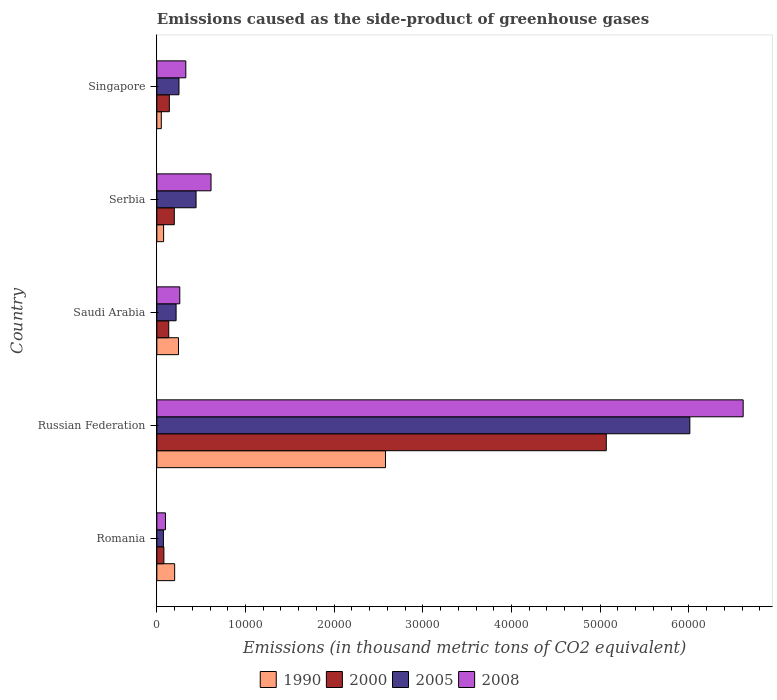How many different coloured bars are there?
Provide a short and direct response. 4. Are the number of bars per tick equal to the number of legend labels?
Your answer should be very brief. Yes. How many bars are there on the 2nd tick from the bottom?
Your answer should be very brief. 4. What is the label of the 2nd group of bars from the top?
Your response must be concise. Serbia. In how many cases, is the number of bars for a given country not equal to the number of legend labels?
Make the answer very short. 0. What is the emissions caused as the side-product of greenhouse gases in 2005 in Saudi Arabia?
Ensure brevity in your answer.  2170.7. Across all countries, what is the maximum emissions caused as the side-product of greenhouse gases in 2008?
Offer a very short reply. 6.61e+04. Across all countries, what is the minimum emissions caused as the side-product of greenhouse gases in 2000?
Make the answer very short. 795.1. In which country was the emissions caused as the side-product of greenhouse gases in 2000 maximum?
Offer a very short reply. Russian Federation. In which country was the emissions caused as the side-product of greenhouse gases in 2005 minimum?
Provide a short and direct response. Romania. What is the total emissions caused as the side-product of greenhouse gases in 1990 in the graph?
Your response must be concise. 3.15e+04. What is the difference between the emissions caused as the side-product of greenhouse gases in 2000 in Romania and that in Saudi Arabia?
Give a very brief answer. -545. What is the difference between the emissions caused as the side-product of greenhouse gases in 2008 in Romania and the emissions caused as the side-product of greenhouse gases in 2000 in Singapore?
Your response must be concise. -439.3. What is the average emissions caused as the side-product of greenhouse gases in 2008 per country?
Give a very brief answer. 1.58e+04. What is the difference between the emissions caused as the side-product of greenhouse gases in 1990 and emissions caused as the side-product of greenhouse gases in 2005 in Saudi Arabia?
Provide a succinct answer. 270.7. In how many countries, is the emissions caused as the side-product of greenhouse gases in 2005 greater than 56000 thousand metric tons?
Ensure brevity in your answer.  1. What is the ratio of the emissions caused as the side-product of greenhouse gases in 2000 in Russian Federation to that in Saudi Arabia?
Provide a succinct answer. 37.82. What is the difference between the highest and the second highest emissions caused as the side-product of greenhouse gases in 2005?
Offer a terse response. 5.57e+04. What is the difference between the highest and the lowest emissions caused as the side-product of greenhouse gases in 2008?
Make the answer very short. 6.52e+04. Is the sum of the emissions caused as the side-product of greenhouse gases in 2000 in Romania and Singapore greater than the maximum emissions caused as the side-product of greenhouse gases in 2005 across all countries?
Provide a short and direct response. No. Is it the case that in every country, the sum of the emissions caused as the side-product of greenhouse gases in 2000 and emissions caused as the side-product of greenhouse gases in 2005 is greater than the sum of emissions caused as the side-product of greenhouse gases in 1990 and emissions caused as the side-product of greenhouse gases in 2008?
Keep it short and to the point. No. What does the 2nd bar from the top in Russian Federation represents?
Keep it short and to the point. 2005. Is it the case that in every country, the sum of the emissions caused as the side-product of greenhouse gases in 2005 and emissions caused as the side-product of greenhouse gases in 2008 is greater than the emissions caused as the side-product of greenhouse gases in 2000?
Ensure brevity in your answer.  Yes. How many countries are there in the graph?
Offer a terse response. 5. Are the values on the major ticks of X-axis written in scientific E-notation?
Provide a succinct answer. No. Where does the legend appear in the graph?
Ensure brevity in your answer.  Bottom center. How many legend labels are there?
Give a very brief answer. 4. How are the legend labels stacked?
Provide a short and direct response. Horizontal. What is the title of the graph?
Provide a succinct answer. Emissions caused as the side-product of greenhouse gases. What is the label or title of the X-axis?
Provide a short and direct response. Emissions (in thousand metric tons of CO2 equivalent). What is the label or title of the Y-axis?
Your answer should be very brief. Country. What is the Emissions (in thousand metric tons of CO2 equivalent) of 1990 in Romania?
Your answer should be compact. 2007.7. What is the Emissions (in thousand metric tons of CO2 equivalent) of 2000 in Romania?
Offer a terse response. 795.1. What is the Emissions (in thousand metric tons of CO2 equivalent) of 2005 in Romania?
Offer a very short reply. 742.3. What is the Emissions (in thousand metric tons of CO2 equivalent) in 2008 in Romania?
Keep it short and to the point. 970.3. What is the Emissions (in thousand metric tons of CO2 equivalent) in 1990 in Russian Federation?
Provide a succinct answer. 2.58e+04. What is the Emissions (in thousand metric tons of CO2 equivalent) in 2000 in Russian Federation?
Provide a succinct answer. 5.07e+04. What is the Emissions (in thousand metric tons of CO2 equivalent) of 2005 in Russian Federation?
Your response must be concise. 6.01e+04. What is the Emissions (in thousand metric tons of CO2 equivalent) of 2008 in Russian Federation?
Your answer should be very brief. 6.61e+04. What is the Emissions (in thousand metric tons of CO2 equivalent) in 1990 in Saudi Arabia?
Provide a succinct answer. 2441.4. What is the Emissions (in thousand metric tons of CO2 equivalent) in 2000 in Saudi Arabia?
Ensure brevity in your answer.  1340.1. What is the Emissions (in thousand metric tons of CO2 equivalent) of 2005 in Saudi Arabia?
Provide a succinct answer. 2170.7. What is the Emissions (in thousand metric tons of CO2 equivalent) of 2008 in Saudi Arabia?
Your answer should be very brief. 2588.3. What is the Emissions (in thousand metric tons of CO2 equivalent) in 1990 in Serbia?
Give a very brief answer. 762.4. What is the Emissions (in thousand metric tons of CO2 equivalent) in 2000 in Serbia?
Give a very brief answer. 1968.1. What is the Emissions (in thousand metric tons of CO2 equivalent) in 2005 in Serbia?
Offer a terse response. 4422.8. What is the Emissions (in thousand metric tons of CO2 equivalent) in 2008 in Serbia?
Offer a very short reply. 6111.3. What is the Emissions (in thousand metric tons of CO2 equivalent) of 1990 in Singapore?
Make the answer very short. 501.5. What is the Emissions (in thousand metric tons of CO2 equivalent) of 2000 in Singapore?
Provide a succinct answer. 1409.6. What is the Emissions (in thousand metric tons of CO2 equivalent) of 2005 in Singapore?
Your answer should be very brief. 2496.4. What is the Emissions (in thousand metric tons of CO2 equivalent) in 2008 in Singapore?
Your answer should be very brief. 3266.4. Across all countries, what is the maximum Emissions (in thousand metric tons of CO2 equivalent) of 1990?
Make the answer very short. 2.58e+04. Across all countries, what is the maximum Emissions (in thousand metric tons of CO2 equivalent) of 2000?
Ensure brevity in your answer.  5.07e+04. Across all countries, what is the maximum Emissions (in thousand metric tons of CO2 equivalent) of 2005?
Your response must be concise. 6.01e+04. Across all countries, what is the maximum Emissions (in thousand metric tons of CO2 equivalent) in 2008?
Your answer should be very brief. 6.61e+04. Across all countries, what is the minimum Emissions (in thousand metric tons of CO2 equivalent) in 1990?
Your answer should be very brief. 501.5. Across all countries, what is the minimum Emissions (in thousand metric tons of CO2 equivalent) in 2000?
Make the answer very short. 795.1. Across all countries, what is the minimum Emissions (in thousand metric tons of CO2 equivalent) of 2005?
Provide a succinct answer. 742.3. Across all countries, what is the minimum Emissions (in thousand metric tons of CO2 equivalent) of 2008?
Provide a short and direct response. 970.3. What is the total Emissions (in thousand metric tons of CO2 equivalent) of 1990 in the graph?
Your response must be concise. 3.15e+04. What is the total Emissions (in thousand metric tons of CO2 equivalent) in 2000 in the graph?
Provide a short and direct response. 5.62e+04. What is the total Emissions (in thousand metric tons of CO2 equivalent) in 2005 in the graph?
Provide a succinct answer. 6.99e+04. What is the total Emissions (in thousand metric tons of CO2 equivalent) of 2008 in the graph?
Provide a succinct answer. 7.91e+04. What is the difference between the Emissions (in thousand metric tons of CO2 equivalent) of 1990 in Romania and that in Russian Federation?
Your answer should be very brief. -2.38e+04. What is the difference between the Emissions (in thousand metric tons of CO2 equivalent) of 2000 in Romania and that in Russian Federation?
Give a very brief answer. -4.99e+04. What is the difference between the Emissions (in thousand metric tons of CO2 equivalent) of 2005 in Romania and that in Russian Federation?
Provide a succinct answer. -5.94e+04. What is the difference between the Emissions (in thousand metric tons of CO2 equivalent) of 2008 in Romania and that in Russian Federation?
Provide a succinct answer. -6.52e+04. What is the difference between the Emissions (in thousand metric tons of CO2 equivalent) in 1990 in Romania and that in Saudi Arabia?
Your response must be concise. -433.7. What is the difference between the Emissions (in thousand metric tons of CO2 equivalent) in 2000 in Romania and that in Saudi Arabia?
Provide a short and direct response. -545. What is the difference between the Emissions (in thousand metric tons of CO2 equivalent) in 2005 in Romania and that in Saudi Arabia?
Ensure brevity in your answer.  -1428.4. What is the difference between the Emissions (in thousand metric tons of CO2 equivalent) in 2008 in Romania and that in Saudi Arabia?
Provide a short and direct response. -1618. What is the difference between the Emissions (in thousand metric tons of CO2 equivalent) of 1990 in Romania and that in Serbia?
Your answer should be very brief. 1245.3. What is the difference between the Emissions (in thousand metric tons of CO2 equivalent) in 2000 in Romania and that in Serbia?
Ensure brevity in your answer.  -1173. What is the difference between the Emissions (in thousand metric tons of CO2 equivalent) in 2005 in Romania and that in Serbia?
Make the answer very short. -3680.5. What is the difference between the Emissions (in thousand metric tons of CO2 equivalent) in 2008 in Romania and that in Serbia?
Provide a short and direct response. -5141. What is the difference between the Emissions (in thousand metric tons of CO2 equivalent) of 1990 in Romania and that in Singapore?
Your answer should be compact. 1506.2. What is the difference between the Emissions (in thousand metric tons of CO2 equivalent) in 2000 in Romania and that in Singapore?
Provide a succinct answer. -614.5. What is the difference between the Emissions (in thousand metric tons of CO2 equivalent) of 2005 in Romania and that in Singapore?
Give a very brief answer. -1754.1. What is the difference between the Emissions (in thousand metric tons of CO2 equivalent) in 2008 in Romania and that in Singapore?
Provide a short and direct response. -2296.1. What is the difference between the Emissions (in thousand metric tons of CO2 equivalent) of 1990 in Russian Federation and that in Saudi Arabia?
Give a very brief answer. 2.33e+04. What is the difference between the Emissions (in thousand metric tons of CO2 equivalent) of 2000 in Russian Federation and that in Saudi Arabia?
Offer a very short reply. 4.93e+04. What is the difference between the Emissions (in thousand metric tons of CO2 equivalent) of 2005 in Russian Federation and that in Saudi Arabia?
Keep it short and to the point. 5.79e+04. What is the difference between the Emissions (in thousand metric tons of CO2 equivalent) of 2008 in Russian Federation and that in Saudi Arabia?
Your answer should be very brief. 6.35e+04. What is the difference between the Emissions (in thousand metric tons of CO2 equivalent) of 1990 in Russian Federation and that in Serbia?
Provide a succinct answer. 2.50e+04. What is the difference between the Emissions (in thousand metric tons of CO2 equivalent) of 2000 in Russian Federation and that in Serbia?
Offer a terse response. 4.87e+04. What is the difference between the Emissions (in thousand metric tons of CO2 equivalent) of 2005 in Russian Federation and that in Serbia?
Your response must be concise. 5.57e+04. What is the difference between the Emissions (in thousand metric tons of CO2 equivalent) of 2008 in Russian Federation and that in Serbia?
Offer a terse response. 6.00e+04. What is the difference between the Emissions (in thousand metric tons of CO2 equivalent) of 1990 in Russian Federation and that in Singapore?
Your answer should be very brief. 2.53e+04. What is the difference between the Emissions (in thousand metric tons of CO2 equivalent) in 2000 in Russian Federation and that in Singapore?
Ensure brevity in your answer.  4.93e+04. What is the difference between the Emissions (in thousand metric tons of CO2 equivalent) of 2005 in Russian Federation and that in Singapore?
Give a very brief answer. 5.76e+04. What is the difference between the Emissions (in thousand metric tons of CO2 equivalent) of 2008 in Russian Federation and that in Singapore?
Ensure brevity in your answer.  6.29e+04. What is the difference between the Emissions (in thousand metric tons of CO2 equivalent) of 1990 in Saudi Arabia and that in Serbia?
Provide a short and direct response. 1679. What is the difference between the Emissions (in thousand metric tons of CO2 equivalent) of 2000 in Saudi Arabia and that in Serbia?
Your answer should be compact. -628. What is the difference between the Emissions (in thousand metric tons of CO2 equivalent) of 2005 in Saudi Arabia and that in Serbia?
Offer a terse response. -2252.1. What is the difference between the Emissions (in thousand metric tons of CO2 equivalent) in 2008 in Saudi Arabia and that in Serbia?
Offer a terse response. -3523. What is the difference between the Emissions (in thousand metric tons of CO2 equivalent) in 1990 in Saudi Arabia and that in Singapore?
Your answer should be very brief. 1939.9. What is the difference between the Emissions (in thousand metric tons of CO2 equivalent) of 2000 in Saudi Arabia and that in Singapore?
Your response must be concise. -69.5. What is the difference between the Emissions (in thousand metric tons of CO2 equivalent) in 2005 in Saudi Arabia and that in Singapore?
Keep it short and to the point. -325.7. What is the difference between the Emissions (in thousand metric tons of CO2 equivalent) of 2008 in Saudi Arabia and that in Singapore?
Give a very brief answer. -678.1. What is the difference between the Emissions (in thousand metric tons of CO2 equivalent) in 1990 in Serbia and that in Singapore?
Your answer should be very brief. 260.9. What is the difference between the Emissions (in thousand metric tons of CO2 equivalent) of 2000 in Serbia and that in Singapore?
Your answer should be very brief. 558.5. What is the difference between the Emissions (in thousand metric tons of CO2 equivalent) in 2005 in Serbia and that in Singapore?
Offer a very short reply. 1926.4. What is the difference between the Emissions (in thousand metric tons of CO2 equivalent) in 2008 in Serbia and that in Singapore?
Keep it short and to the point. 2844.9. What is the difference between the Emissions (in thousand metric tons of CO2 equivalent) in 1990 in Romania and the Emissions (in thousand metric tons of CO2 equivalent) in 2000 in Russian Federation?
Keep it short and to the point. -4.87e+04. What is the difference between the Emissions (in thousand metric tons of CO2 equivalent) in 1990 in Romania and the Emissions (in thousand metric tons of CO2 equivalent) in 2005 in Russian Federation?
Your response must be concise. -5.81e+04. What is the difference between the Emissions (in thousand metric tons of CO2 equivalent) in 1990 in Romania and the Emissions (in thousand metric tons of CO2 equivalent) in 2008 in Russian Federation?
Your response must be concise. -6.41e+04. What is the difference between the Emissions (in thousand metric tons of CO2 equivalent) in 2000 in Romania and the Emissions (in thousand metric tons of CO2 equivalent) in 2005 in Russian Federation?
Provide a short and direct response. -5.93e+04. What is the difference between the Emissions (in thousand metric tons of CO2 equivalent) of 2000 in Romania and the Emissions (in thousand metric tons of CO2 equivalent) of 2008 in Russian Federation?
Make the answer very short. -6.53e+04. What is the difference between the Emissions (in thousand metric tons of CO2 equivalent) of 2005 in Romania and the Emissions (in thousand metric tons of CO2 equivalent) of 2008 in Russian Federation?
Give a very brief answer. -6.54e+04. What is the difference between the Emissions (in thousand metric tons of CO2 equivalent) of 1990 in Romania and the Emissions (in thousand metric tons of CO2 equivalent) of 2000 in Saudi Arabia?
Give a very brief answer. 667.6. What is the difference between the Emissions (in thousand metric tons of CO2 equivalent) in 1990 in Romania and the Emissions (in thousand metric tons of CO2 equivalent) in 2005 in Saudi Arabia?
Offer a very short reply. -163. What is the difference between the Emissions (in thousand metric tons of CO2 equivalent) in 1990 in Romania and the Emissions (in thousand metric tons of CO2 equivalent) in 2008 in Saudi Arabia?
Your response must be concise. -580.6. What is the difference between the Emissions (in thousand metric tons of CO2 equivalent) in 2000 in Romania and the Emissions (in thousand metric tons of CO2 equivalent) in 2005 in Saudi Arabia?
Your answer should be very brief. -1375.6. What is the difference between the Emissions (in thousand metric tons of CO2 equivalent) in 2000 in Romania and the Emissions (in thousand metric tons of CO2 equivalent) in 2008 in Saudi Arabia?
Offer a terse response. -1793.2. What is the difference between the Emissions (in thousand metric tons of CO2 equivalent) of 2005 in Romania and the Emissions (in thousand metric tons of CO2 equivalent) of 2008 in Saudi Arabia?
Keep it short and to the point. -1846. What is the difference between the Emissions (in thousand metric tons of CO2 equivalent) of 1990 in Romania and the Emissions (in thousand metric tons of CO2 equivalent) of 2000 in Serbia?
Keep it short and to the point. 39.6. What is the difference between the Emissions (in thousand metric tons of CO2 equivalent) in 1990 in Romania and the Emissions (in thousand metric tons of CO2 equivalent) in 2005 in Serbia?
Offer a very short reply. -2415.1. What is the difference between the Emissions (in thousand metric tons of CO2 equivalent) in 1990 in Romania and the Emissions (in thousand metric tons of CO2 equivalent) in 2008 in Serbia?
Your answer should be compact. -4103.6. What is the difference between the Emissions (in thousand metric tons of CO2 equivalent) in 2000 in Romania and the Emissions (in thousand metric tons of CO2 equivalent) in 2005 in Serbia?
Provide a short and direct response. -3627.7. What is the difference between the Emissions (in thousand metric tons of CO2 equivalent) of 2000 in Romania and the Emissions (in thousand metric tons of CO2 equivalent) of 2008 in Serbia?
Provide a succinct answer. -5316.2. What is the difference between the Emissions (in thousand metric tons of CO2 equivalent) in 2005 in Romania and the Emissions (in thousand metric tons of CO2 equivalent) in 2008 in Serbia?
Provide a short and direct response. -5369. What is the difference between the Emissions (in thousand metric tons of CO2 equivalent) of 1990 in Romania and the Emissions (in thousand metric tons of CO2 equivalent) of 2000 in Singapore?
Offer a terse response. 598.1. What is the difference between the Emissions (in thousand metric tons of CO2 equivalent) in 1990 in Romania and the Emissions (in thousand metric tons of CO2 equivalent) in 2005 in Singapore?
Your answer should be very brief. -488.7. What is the difference between the Emissions (in thousand metric tons of CO2 equivalent) of 1990 in Romania and the Emissions (in thousand metric tons of CO2 equivalent) of 2008 in Singapore?
Provide a short and direct response. -1258.7. What is the difference between the Emissions (in thousand metric tons of CO2 equivalent) of 2000 in Romania and the Emissions (in thousand metric tons of CO2 equivalent) of 2005 in Singapore?
Offer a terse response. -1701.3. What is the difference between the Emissions (in thousand metric tons of CO2 equivalent) in 2000 in Romania and the Emissions (in thousand metric tons of CO2 equivalent) in 2008 in Singapore?
Ensure brevity in your answer.  -2471.3. What is the difference between the Emissions (in thousand metric tons of CO2 equivalent) of 2005 in Romania and the Emissions (in thousand metric tons of CO2 equivalent) of 2008 in Singapore?
Your response must be concise. -2524.1. What is the difference between the Emissions (in thousand metric tons of CO2 equivalent) in 1990 in Russian Federation and the Emissions (in thousand metric tons of CO2 equivalent) in 2000 in Saudi Arabia?
Ensure brevity in your answer.  2.44e+04. What is the difference between the Emissions (in thousand metric tons of CO2 equivalent) of 1990 in Russian Federation and the Emissions (in thousand metric tons of CO2 equivalent) of 2005 in Saudi Arabia?
Your response must be concise. 2.36e+04. What is the difference between the Emissions (in thousand metric tons of CO2 equivalent) of 1990 in Russian Federation and the Emissions (in thousand metric tons of CO2 equivalent) of 2008 in Saudi Arabia?
Provide a succinct answer. 2.32e+04. What is the difference between the Emissions (in thousand metric tons of CO2 equivalent) of 2000 in Russian Federation and the Emissions (in thousand metric tons of CO2 equivalent) of 2005 in Saudi Arabia?
Provide a short and direct response. 4.85e+04. What is the difference between the Emissions (in thousand metric tons of CO2 equivalent) of 2000 in Russian Federation and the Emissions (in thousand metric tons of CO2 equivalent) of 2008 in Saudi Arabia?
Provide a short and direct response. 4.81e+04. What is the difference between the Emissions (in thousand metric tons of CO2 equivalent) in 2005 in Russian Federation and the Emissions (in thousand metric tons of CO2 equivalent) in 2008 in Saudi Arabia?
Keep it short and to the point. 5.75e+04. What is the difference between the Emissions (in thousand metric tons of CO2 equivalent) of 1990 in Russian Federation and the Emissions (in thousand metric tons of CO2 equivalent) of 2000 in Serbia?
Offer a terse response. 2.38e+04. What is the difference between the Emissions (in thousand metric tons of CO2 equivalent) in 1990 in Russian Federation and the Emissions (in thousand metric tons of CO2 equivalent) in 2005 in Serbia?
Your response must be concise. 2.14e+04. What is the difference between the Emissions (in thousand metric tons of CO2 equivalent) in 1990 in Russian Federation and the Emissions (in thousand metric tons of CO2 equivalent) in 2008 in Serbia?
Ensure brevity in your answer.  1.97e+04. What is the difference between the Emissions (in thousand metric tons of CO2 equivalent) of 2000 in Russian Federation and the Emissions (in thousand metric tons of CO2 equivalent) of 2005 in Serbia?
Your response must be concise. 4.63e+04. What is the difference between the Emissions (in thousand metric tons of CO2 equivalent) of 2000 in Russian Federation and the Emissions (in thousand metric tons of CO2 equivalent) of 2008 in Serbia?
Offer a very short reply. 4.46e+04. What is the difference between the Emissions (in thousand metric tons of CO2 equivalent) in 2005 in Russian Federation and the Emissions (in thousand metric tons of CO2 equivalent) in 2008 in Serbia?
Give a very brief answer. 5.40e+04. What is the difference between the Emissions (in thousand metric tons of CO2 equivalent) of 1990 in Russian Federation and the Emissions (in thousand metric tons of CO2 equivalent) of 2000 in Singapore?
Keep it short and to the point. 2.44e+04. What is the difference between the Emissions (in thousand metric tons of CO2 equivalent) of 1990 in Russian Federation and the Emissions (in thousand metric tons of CO2 equivalent) of 2005 in Singapore?
Make the answer very short. 2.33e+04. What is the difference between the Emissions (in thousand metric tons of CO2 equivalent) in 1990 in Russian Federation and the Emissions (in thousand metric tons of CO2 equivalent) in 2008 in Singapore?
Your answer should be compact. 2.25e+04. What is the difference between the Emissions (in thousand metric tons of CO2 equivalent) of 2000 in Russian Federation and the Emissions (in thousand metric tons of CO2 equivalent) of 2005 in Singapore?
Your response must be concise. 4.82e+04. What is the difference between the Emissions (in thousand metric tons of CO2 equivalent) of 2000 in Russian Federation and the Emissions (in thousand metric tons of CO2 equivalent) of 2008 in Singapore?
Your answer should be very brief. 4.74e+04. What is the difference between the Emissions (in thousand metric tons of CO2 equivalent) of 2005 in Russian Federation and the Emissions (in thousand metric tons of CO2 equivalent) of 2008 in Singapore?
Make the answer very short. 5.68e+04. What is the difference between the Emissions (in thousand metric tons of CO2 equivalent) in 1990 in Saudi Arabia and the Emissions (in thousand metric tons of CO2 equivalent) in 2000 in Serbia?
Ensure brevity in your answer.  473.3. What is the difference between the Emissions (in thousand metric tons of CO2 equivalent) of 1990 in Saudi Arabia and the Emissions (in thousand metric tons of CO2 equivalent) of 2005 in Serbia?
Provide a short and direct response. -1981.4. What is the difference between the Emissions (in thousand metric tons of CO2 equivalent) in 1990 in Saudi Arabia and the Emissions (in thousand metric tons of CO2 equivalent) in 2008 in Serbia?
Provide a succinct answer. -3669.9. What is the difference between the Emissions (in thousand metric tons of CO2 equivalent) of 2000 in Saudi Arabia and the Emissions (in thousand metric tons of CO2 equivalent) of 2005 in Serbia?
Make the answer very short. -3082.7. What is the difference between the Emissions (in thousand metric tons of CO2 equivalent) of 2000 in Saudi Arabia and the Emissions (in thousand metric tons of CO2 equivalent) of 2008 in Serbia?
Make the answer very short. -4771.2. What is the difference between the Emissions (in thousand metric tons of CO2 equivalent) in 2005 in Saudi Arabia and the Emissions (in thousand metric tons of CO2 equivalent) in 2008 in Serbia?
Offer a very short reply. -3940.6. What is the difference between the Emissions (in thousand metric tons of CO2 equivalent) in 1990 in Saudi Arabia and the Emissions (in thousand metric tons of CO2 equivalent) in 2000 in Singapore?
Your answer should be compact. 1031.8. What is the difference between the Emissions (in thousand metric tons of CO2 equivalent) in 1990 in Saudi Arabia and the Emissions (in thousand metric tons of CO2 equivalent) in 2005 in Singapore?
Provide a short and direct response. -55. What is the difference between the Emissions (in thousand metric tons of CO2 equivalent) of 1990 in Saudi Arabia and the Emissions (in thousand metric tons of CO2 equivalent) of 2008 in Singapore?
Ensure brevity in your answer.  -825. What is the difference between the Emissions (in thousand metric tons of CO2 equivalent) in 2000 in Saudi Arabia and the Emissions (in thousand metric tons of CO2 equivalent) in 2005 in Singapore?
Offer a terse response. -1156.3. What is the difference between the Emissions (in thousand metric tons of CO2 equivalent) of 2000 in Saudi Arabia and the Emissions (in thousand metric tons of CO2 equivalent) of 2008 in Singapore?
Offer a very short reply. -1926.3. What is the difference between the Emissions (in thousand metric tons of CO2 equivalent) in 2005 in Saudi Arabia and the Emissions (in thousand metric tons of CO2 equivalent) in 2008 in Singapore?
Give a very brief answer. -1095.7. What is the difference between the Emissions (in thousand metric tons of CO2 equivalent) in 1990 in Serbia and the Emissions (in thousand metric tons of CO2 equivalent) in 2000 in Singapore?
Your answer should be compact. -647.2. What is the difference between the Emissions (in thousand metric tons of CO2 equivalent) of 1990 in Serbia and the Emissions (in thousand metric tons of CO2 equivalent) of 2005 in Singapore?
Give a very brief answer. -1734. What is the difference between the Emissions (in thousand metric tons of CO2 equivalent) of 1990 in Serbia and the Emissions (in thousand metric tons of CO2 equivalent) of 2008 in Singapore?
Give a very brief answer. -2504. What is the difference between the Emissions (in thousand metric tons of CO2 equivalent) in 2000 in Serbia and the Emissions (in thousand metric tons of CO2 equivalent) in 2005 in Singapore?
Give a very brief answer. -528.3. What is the difference between the Emissions (in thousand metric tons of CO2 equivalent) of 2000 in Serbia and the Emissions (in thousand metric tons of CO2 equivalent) of 2008 in Singapore?
Give a very brief answer. -1298.3. What is the difference between the Emissions (in thousand metric tons of CO2 equivalent) in 2005 in Serbia and the Emissions (in thousand metric tons of CO2 equivalent) in 2008 in Singapore?
Offer a very short reply. 1156.4. What is the average Emissions (in thousand metric tons of CO2 equivalent) of 1990 per country?
Provide a short and direct response. 6300.32. What is the average Emissions (in thousand metric tons of CO2 equivalent) in 2000 per country?
Your answer should be very brief. 1.12e+04. What is the average Emissions (in thousand metric tons of CO2 equivalent) of 2005 per country?
Provide a succinct answer. 1.40e+04. What is the average Emissions (in thousand metric tons of CO2 equivalent) in 2008 per country?
Ensure brevity in your answer.  1.58e+04. What is the difference between the Emissions (in thousand metric tons of CO2 equivalent) in 1990 and Emissions (in thousand metric tons of CO2 equivalent) in 2000 in Romania?
Your answer should be very brief. 1212.6. What is the difference between the Emissions (in thousand metric tons of CO2 equivalent) of 1990 and Emissions (in thousand metric tons of CO2 equivalent) of 2005 in Romania?
Keep it short and to the point. 1265.4. What is the difference between the Emissions (in thousand metric tons of CO2 equivalent) in 1990 and Emissions (in thousand metric tons of CO2 equivalent) in 2008 in Romania?
Provide a short and direct response. 1037.4. What is the difference between the Emissions (in thousand metric tons of CO2 equivalent) of 2000 and Emissions (in thousand metric tons of CO2 equivalent) of 2005 in Romania?
Provide a succinct answer. 52.8. What is the difference between the Emissions (in thousand metric tons of CO2 equivalent) of 2000 and Emissions (in thousand metric tons of CO2 equivalent) of 2008 in Romania?
Give a very brief answer. -175.2. What is the difference between the Emissions (in thousand metric tons of CO2 equivalent) in 2005 and Emissions (in thousand metric tons of CO2 equivalent) in 2008 in Romania?
Your answer should be very brief. -228. What is the difference between the Emissions (in thousand metric tons of CO2 equivalent) in 1990 and Emissions (in thousand metric tons of CO2 equivalent) in 2000 in Russian Federation?
Ensure brevity in your answer.  -2.49e+04. What is the difference between the Emissions (in thousand metric tons of CO2 equivalent) of 1990 and Emissions (in thousand metric tons of CO2 equivalent) of 2005 in Russian Federation?
Provide a short and direct response. -3.43e+04. What is the difference between the Emissions (in thousand metric tons of CO2 equivalent) in 1990 and Emissions (in thousand metric tons of CO2 equivalent) in 2008 in Russian Federation?
Give a very brief answer. -4.03e+04. What is the difference between the Emissions (in thousand metric tons of CO2 equivalent) in 2000 and Emissions (in thousand metric tons of CO2 equivalent) in 2005 in Russian Federation?
Offer a terse response. -9424.5. What is the difference between the Emissions (in thousand metric tons of CO2 equivalent) in 2000 and Emissions (in thousand metric tons of CO2 equivalent) in 2008 in Russian Federation?
Your answer should be very brief. -1.54e+04. What is the difference between the Emissions (in thousand metric tons of CO2 equivalent) in 2005 and Emissions (in thousand metric tons of CO2 equivalent) in 2008 in Russian Federation?
Give a very brief answer. -6015. What is the difference between the Emissions (in thousand metric tons of CO2 equivalent) of 1990 and Emissions (in thousand metric tons of CO2 equivalent) of 2000 in Saudi Arabia?
Your answer should be compact. 1101.3. What is the difference between the Emissions (in thousand metric tons of CO2 equivalent) in 1990 and Emissions (in thousand metric tons of CO2 equivalent) in 2005 in Saudi Arabia?
Your answer should be compact. 270.7. What is the difference between the Emissions (in thousand metric tons of CO2 equivalent) of 1990 and Emissions (in thousand metric tons of CO2 equivalent) of 2008 in Saudi Arabia?
Keep it short and to the point. -146.9. What is the difference between the Emissions (in thousand metric tons of CO2 equivalent) in 2000 and Emissions (in thousand metric tons of CO2 equivalent) in 2005 in Saudi Arabia?
Give a very brief answer. -830.6. What is the difference between the Emissions (in thousand metric tons of CO2 equivalent) in 2000 and Emissions (in thousand metric tons of CO2 equivalent) in 2008 in Saudi Arabia?
Your answer should be very brief. -1248.2. What is the difference between the Emissions (in thousand metric tons of CO2 equivalent) in 2005 and Emissions (in thousand metric tons of CO2 equivalent) in 2008 in Saudi Arabia?
Ensure brevity in your answer.  -417.6. What is the difference between the Emissions (in thousand metric tons of CO2 equivalent) in 1990 and Emissions (in thousand metric tons of CO2 equivalent) in 2000 in Serbia?
Offer a terse response. -1205.7. What is the difference between the Emissions (in thousand metric tons of CO2 equivalent) of 1990 and Emissions (in thousand metric tons of CO2 equivalent) of 2005 in Serbia?
Give a very brief answer. -3660.4. What is the difference between the Emissions (in thousand metric tons of CO2 equivalent) of 1990 and Emissions (in thousand metric tons of CO2 equivalent) of 2008 in Serbia?
Give a very brief answer. -5348.9. What is the difference between the Emissions (in thousand metric tons of CO2 equivalent) of 2000 and Emissions (in thousand metric tons of CO2 equivalent) of 2005 in Serbia?
Provide a short and direct response. -2454.7. What is the difference between the Emissions (in thousand metric tons of CO2 equivalent) in 2000 and Emissions (in thousand metric tons of CO2 equivalent) in 2008 in Serbia?
Give a very brief answer. -4143.2. What is the difference between the Emissions (in thousand metric tons of CO2 equivalent) in 2005 and Emissions (in thousand metric tons of CO2 equivalent) in 2008 in Serbia?
Provide a succinct answer. -1688.5. What is the difference between the Emissions (in thousand metric tons of CO2 equivalent) of 1990 and Emissions (in thousand metric tons of CO2 equivalent) of 2000 in Singapore?
Your response must be concise. -908.1. What is the difference between the Emissions (in thousand metric tons of CO2 equivalent) in 1990 and Emissions (in thousand metric tons of CO2 equivalent) in 2005 in Singapore?
Provide a succinct answer. -1994.9. What is the difference between the Emissions (in thousand metric tons of CO2 equivalent) in 1990 and Emissions (in thousand metric tons of CO2 equivalent) in 2008 in Singapore?
Make the answer very short. -2764.9. What is the difference between the Emissions (in thousand metric tons of CO2 equivalent) of 2000 and Emissions (in thousand metric tons of CO2 equivalent) of 2005 in Singapore?
Your response must be concise. -1086.8. What is the difference between the Emissions (in thousand metric tons of CO2 equivalent) of 2000 and Emissions (in thousand metric tons of CO2 equivalent) of 2008 in Singapore?
Keep it short and to the point. -1856.8. What is the difference between the Emissions (in thousand metric tons of CO2 equivalent) of 2005 and Emissions (in thousand metric tons of CO2 equivalent) of 2008 in Singapore?
Offer a terse response. -770. What is the ratio of the Emissions (in thousand metric tons of CO2 equivalent) of 1990 in Romania to that in Russian Federation?
Keep it short and to the point. 0.08. What is the ratio of the Emissions (in thousand metric tons of CO2 equivalent) of 2000 in Romania to that in Russian Federation?
Keep it short and to the point. 0.02. What is the ratio of the Emissions (in thousand metric tons of CO2 equivalent) of 2005 in Romania to that in Russian Federation?
Keep it short and to the point. 0.01. What is the ratio of the Emissions (in thousand metric tons of CO2 equivalent) in 2008 in Romania to that in Russian Federation?
Offer a very short reply. 0.01. What is the ratio of the Emissions (in thousand metric tons of CO2 equivalent) in 1990 in Romania to that in Saudi Arabia?
Keep it short and to the point. 0.82. What is the ratio of the Emissions (in thousand metric tons of CO2 equivalent) in 2000 in Romania to that in Saudi Arabia?
Offer a terse response. 0.59. What is the ratio of the Emissions (in thousand metric tons of CO2 equivalent) of 2005 in Romania to that in Saudi Arabia?
Offer a terse response. 0.34. What is the ratio of the Emissions (in thousand metric tons of CO2 equivalent) of 2008 in Romania to that in Saudi Arabia?
Your response must be concise. 0.37. What is the ratio of the Emissions (in thousand metric tons of CO2 equivalent) in 1990 in Romania to that in Serbia?
Provide a short and direct response. 2.63. What is the ratio of the Emissions (in thousand metric tons of CO2 equivalent) in 2000 in Romania to that in Serbia?
Make the answer very short. 0.4. What is the ratio of the Emissions (in thousand metric tons of CO2 equivalent) of 2005 in Romania to that in Serbia?
Ensure brevity in your answer.  0.17. What is the ratio of the Emissions (in thousand metric tons of CO2 equivalent) of 2008 in Romania to that in Serbia?
Offer a terse response. 0.16. What is the ratio of the Emissions (in thousand metric tons of CO2 equivalent) in 1990 in Romania to that in Singapore?
Your answer should be very brief. 4. What is the ratio of the Emissions (in thousand metric tons of CO2 equivalent) of 2000 in Romania to that in Singapore?
Your answer should be compact. 0.56. What is the ratio of the Emissions (in thousand metric tons of CO2 equivalent) in 2005 in Romania to that in Singapore?
Make the answer very short. 0.3. What is the ratio of the Emissions (in thousand metric tons of CO2 equivalent) of 2008 in Romania to that in Singapore?
Offer a very short reply. 0.3. What is the ratio of the Emissions (in thousand metric tons of CO2 equivalent) in 1990 in Russian Federation to that in Saudi Arabia?
Your answer should be very brief. 10.56. What is the ratio of the Emissions (in thousand metric tons of CO2 equivalent) in 2000 in Russian Federation to that in Saudi Arabia?
Your answer should be very brief. 37.82. What is the ratio of the Emissions (in thousand metric tons of CO2 equivalent) of 2005 in Russian Federation to that in Saudi Arabia?
Give a very brief answer. 27.69. What is the ratio of the Emissions (in thousand metric tons of CO2 equivalent) in 2008 in Russian Federation to that in Saudi Arabia?
Provide a succinct answer. 25.55. What is the ratio of the Emissions (in thousand metric tons of CO2 equivalent) in 1990 in Russian Federation to that in Serbia?
Offer a very short reply. 33.83. What is the ratio of the Emissions (in thousand metric tons of CO2 equivalent) of 2000 in Russian Federation to that in Serbia?
Provide a succinct answer. 25.75. What is the ratio of the Emissions (in thousand metric tons of CO2 equivalent) of 2005 in Russian Federation to that in Serbia?
Give a very brief answer. 13.59. What is the ratio of the Emissions (in thousand metric tons of CO2 equivalent) of 2008 in Russian Federation to that in Serbia?
Provide a succinct answer. 10.82. What is the ratio of the Emissions (in thousand metric tons of CO2 equivalent) in 1990 in Russian Federation to that in Singapore?
Make the answer very short. 51.42. What is the ratio of the Emissions (in thousand metric tons of CO2 equivalent) of 2000 in Russian Federation to that in Singapore?
Offer a terse response. 35.96. What is the ratio of the Emissions (in thousand metric tons of CO2 equivalent) of 2005 in Russian Federation to that in Singapore?
Offer a terse response. 24.08. What is the ratio of the Emissions (in thousand metric tons of CO2 equivalent) in 2008 in Russian Federation to that in Singapore?
Ensure brevity in your answer.  20.24. What is the ratio of the Emissions (in thousand metric tons of CO2 equivalent) of 1990 in Saudi Arabia to that in Serbia?
Offer a terse response. 3.2. What is the ratio of the Emissions (in thousand metric tons of CO2 equivalent) of 2000 in Saudi Arabia to that in Serbia?
Offer a very short reply. 0.68. What is the ratio of the Emissions (in thousand metric tons of CO2 equivalent) in 2005 in Saudi Arabia to that in Serbia?
Provide a short and direct response. 0.49. What is the ratio of the Emissions (in thousand metric tons of CO2 equivalent) in 2008 in Saudi Arabia to that in Serbia?
Make the answer very short. 0.42. What is the ratio of the Emissions (in thousand metric tons of CO2 equivalent) in 1990 in Saudi Arabia to that in Singapore?
Give a very brief answer. 4.87. What is the ratio of the Emissions (in thousand metric tons of CO2 equivalent) of 2000 in Saudi Arabia to that in Singapore?
Make the answer very short. 0.95. What is the ratio of the Emissions (in thousand metric tons of CO2 equivalent) in 2005 in Saudi Arabia to that in Singapore?
Keep it short and to the point. 0.87. What is the ratio of the Emissions (in thousand metric tons of CO2 equivalent) in 2008 in Saudi Arabia to that in Singapore?
Your answer should be compact. 0.79. What is the ratio of the Emissions (in thousand metric tons of CO2 equivalent) of 1990 in Serbia to that in Singapore?
Provide a short and direct response. 1.52. What is the ratio of the Emissions (in thousand metric tons of CO2 equivalent) in 2000 in Serbia to that in Singapore?
Give a very brief answer. 1.4. What is the ratio of the Emissions (in thousand metric tons of CO2 equivalent) in 2005 in Serbia to that in Singapore?
Make the answer very short. 1.77. What is the ratio of the Emissions (in thousand metric tons of CO2 equivalent) of 2008 in Serbia to that in Singapore?
Provide a succinct answer. 1.87. What is the difference between the highest and the second highest Emissions (in thousand metric tons of CO2 equivalent) in 1990?
Keep it short and to the point. 2.33e+04. What is the difference between the highest and the second highest Emissions (in thousand metric tons of CO2 equivalent) of 2000?
Provide a succinct answer. 4.87e+04. What is the difference between the highest and the second highest Emissions (in thousand metric tons of CO2 equivalent) of 2005?
Offer a very short reply. 5.57e+04. What is the difference between the highest and the second highest Emissions (in thousand metric tons of CO2 equivalent) of 2008?
Give a very brief answer. 6.00e+04. What is the difference between the highest and the lowest Emissions (in thousand metric tons of CO2 equivalent) of 1990?
Keep it short and to the point. 2.53e+04. What is the difference between the highest and the lowest Emissions (in thousand metric tons of CO2 equivalent) of 2000?
Offer a terse response. 4.99e+04. What is the difference between the highest and the lowest Emissions (in thousand metric tons of CO2 equivalent) of 2005?
Keep it short and to the point. 5.94e+04. What is the difference between the highest and the lowest Emissions (in thousand metric tons of CO2 equivalent) of 2008?
Your answer should be very brief. 6.52e+04. 